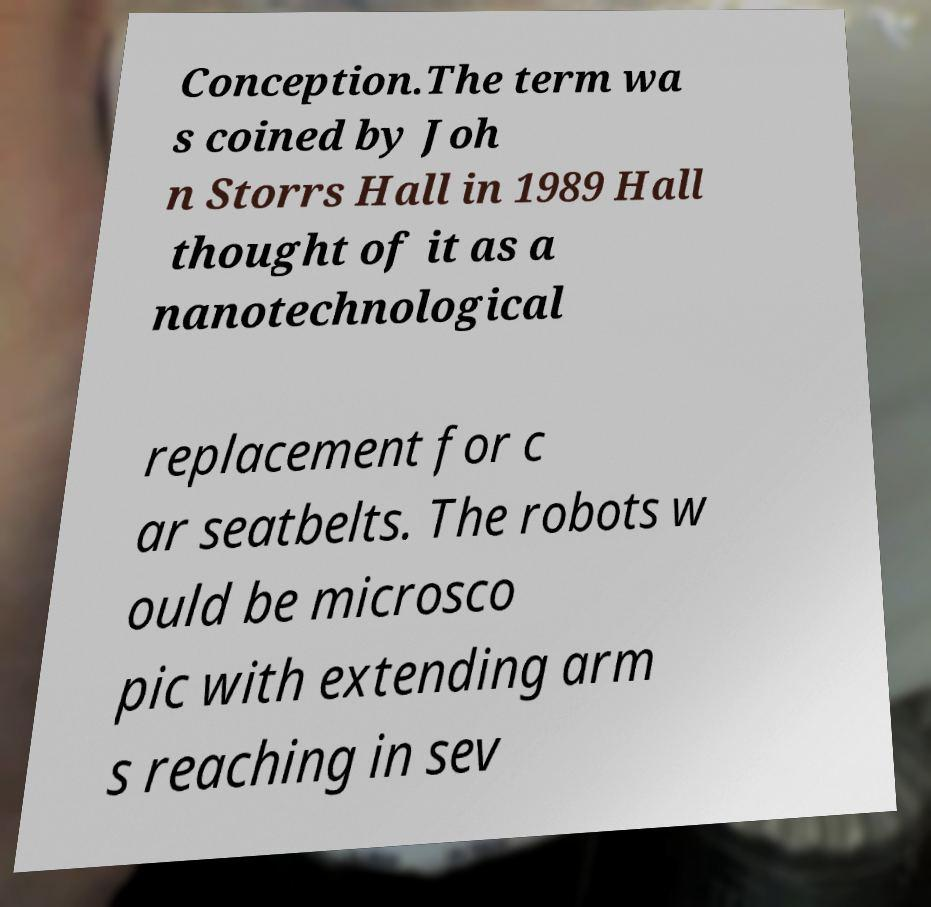Can you accurately transcribe the text from the provided image for me? Conception.The term wa s coined by Joh n Storrs Hall in 1989 Hall thought of it as a nanotechnological replacement for c ar seatbelts. The robots w ould be microsco pic with extending arm s reaching in sev 